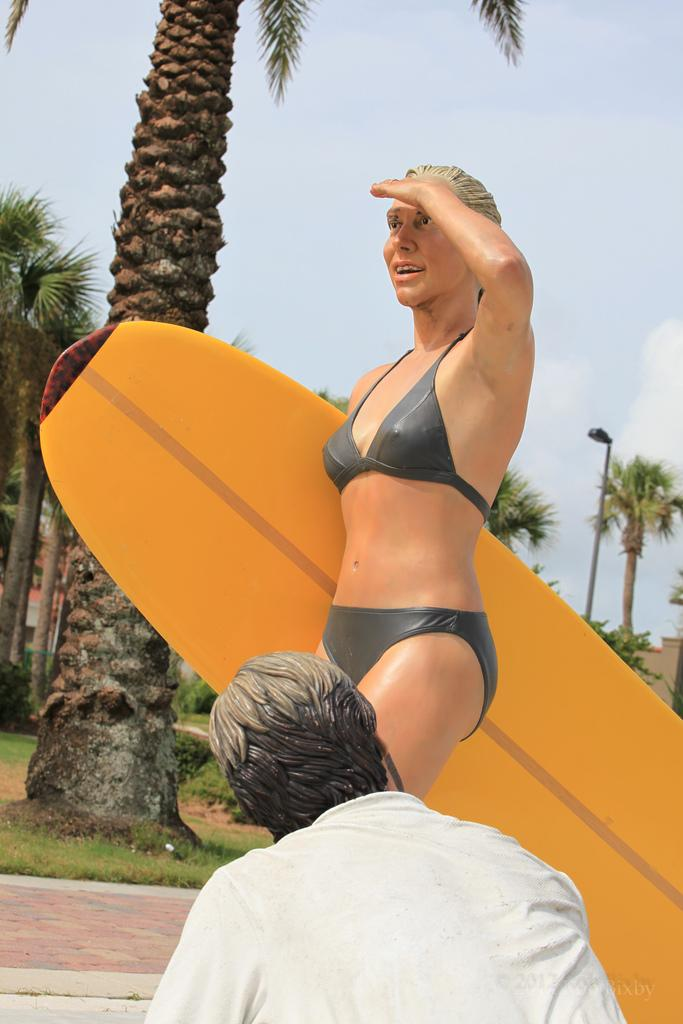What is the main subject of the image? There is a statue of a woman in the image. What is the woman in the statue wearing? The woman is wearing a bikini. What object is the woman holding in the statue? The woman is holding a skateboard. Can you describe the other person in the image? The other person is sitting in front of the statue. What type of work is the woman doing with the spiders in the image? There are no spiders present in the image, and the woman is a statue, so she is not performing any work. What rhythm is the statue dancing to in the image? The statue is not dancing, so there is no rhythm associated with it. 